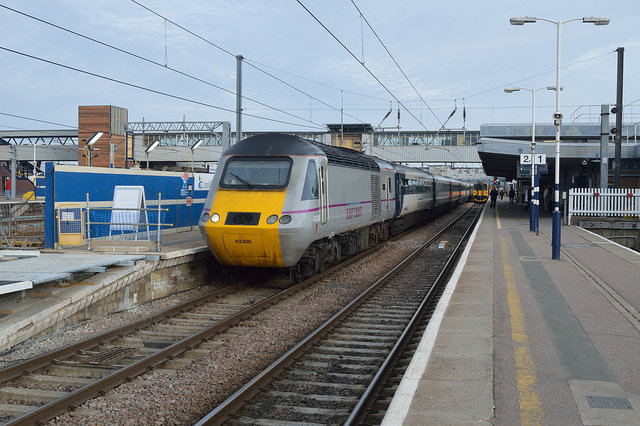Please transcribe the text information in this image. 2 1 